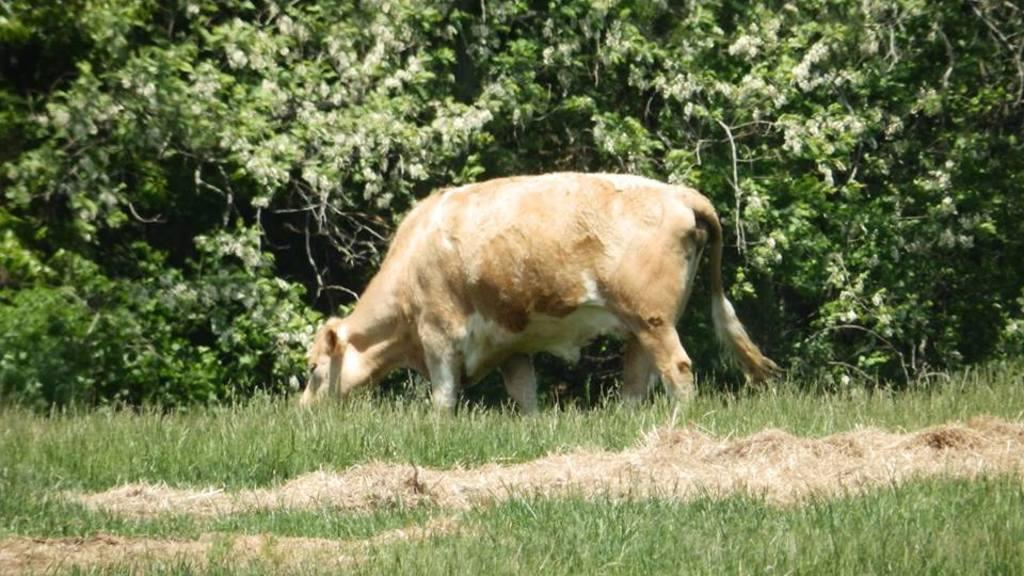What type of creature is present in the image? There is an animal in the image. What is the animal doing in the image? The animal is gazing. What can be seen in the background of the image? There are trees and grass in the background of the image. What type of sand can be seen in the image? There is no sand present in the image. Is the animal showing any signs of fear in the image? The provided facts do not mention any emotions or expressions of the animal, so it cannot be determined if the animal is showing fear. 